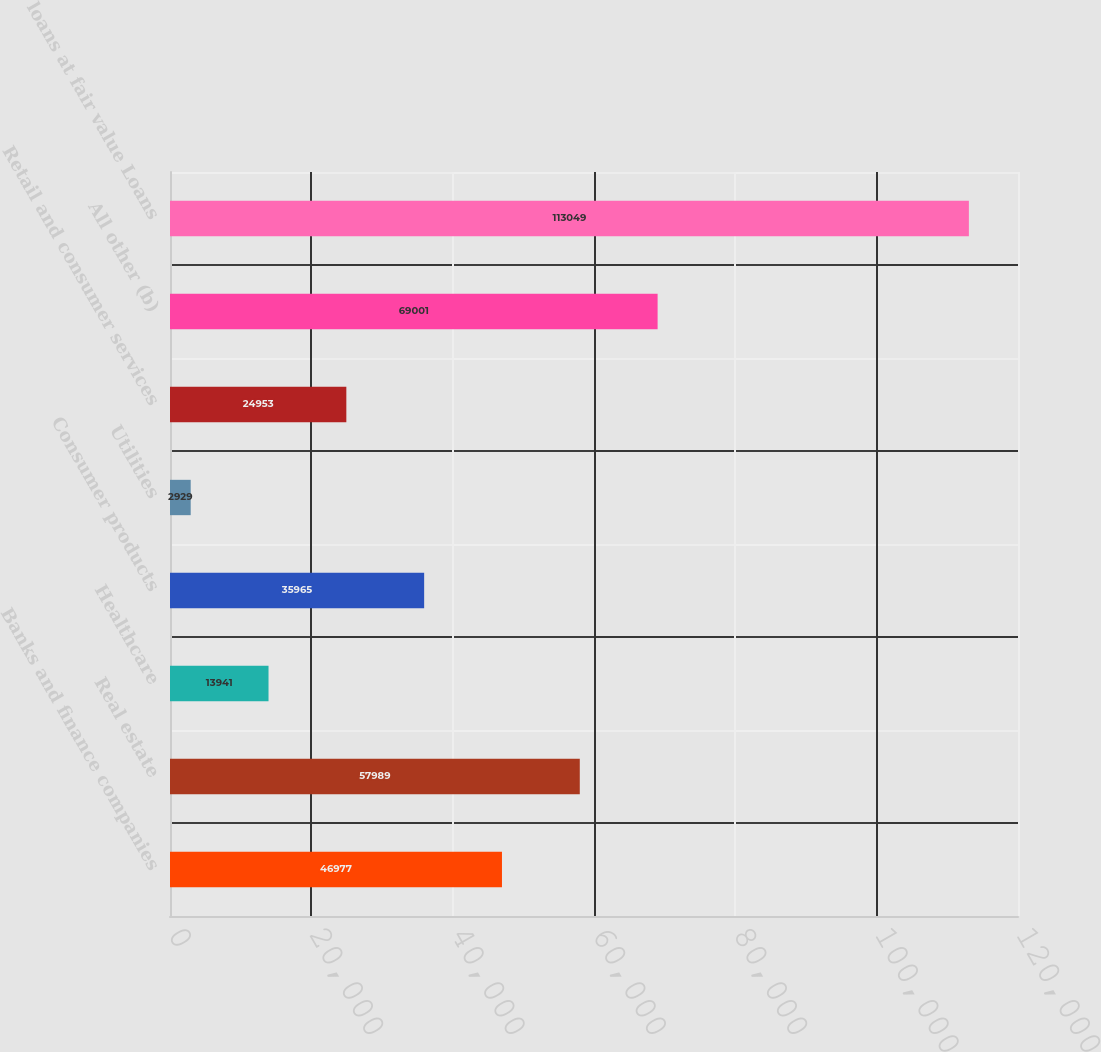<chart> <loc_0><loc_0><loc_500><loc_500><bar_chart><fcel>Banks and finance companies<fcel>Real estate<fcel>Healthcare<fcel>Consumer products<fcel>Utilities<fcel>Retail and consumer services<fcel>All other (b)<fcel>loans at fair value Loans<nl><fcel>46977<fcel>57989<fcel>13941<fcel>35965<fcel>2929<fcel>24953<fcel>69001<fcel>113049<nl></chart> 